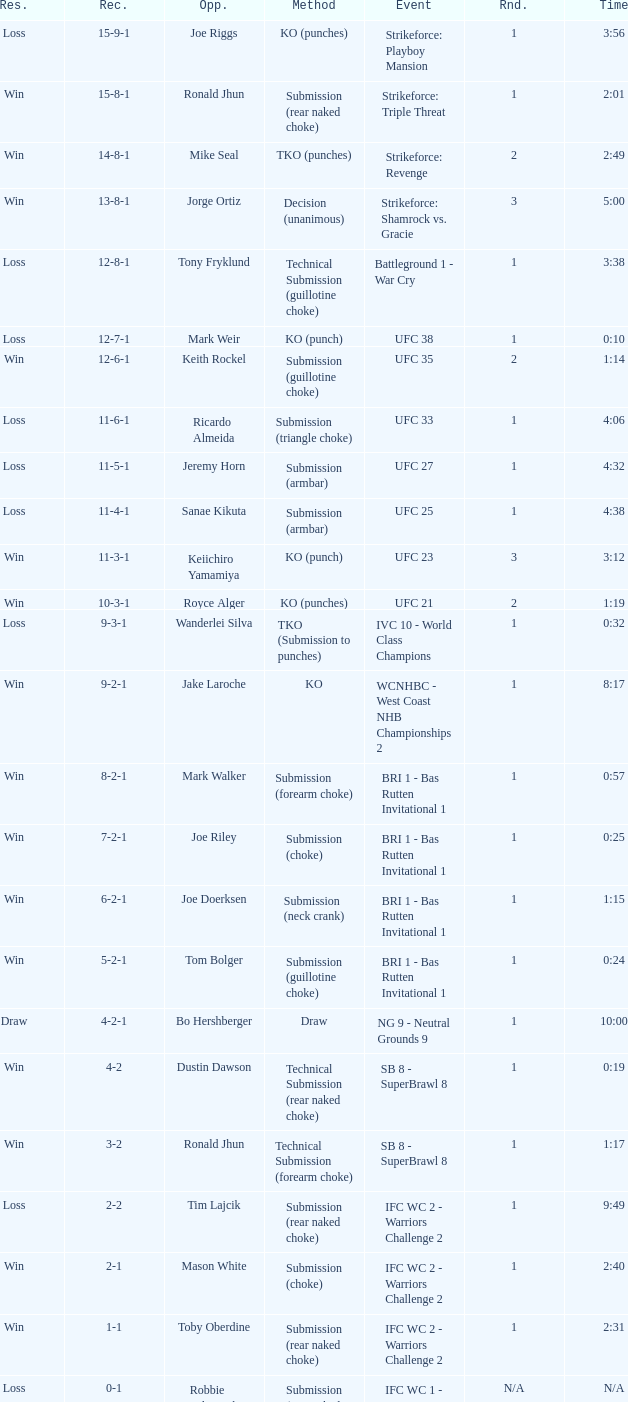What was the record when the method of resolution was KO? 9-2-1. 